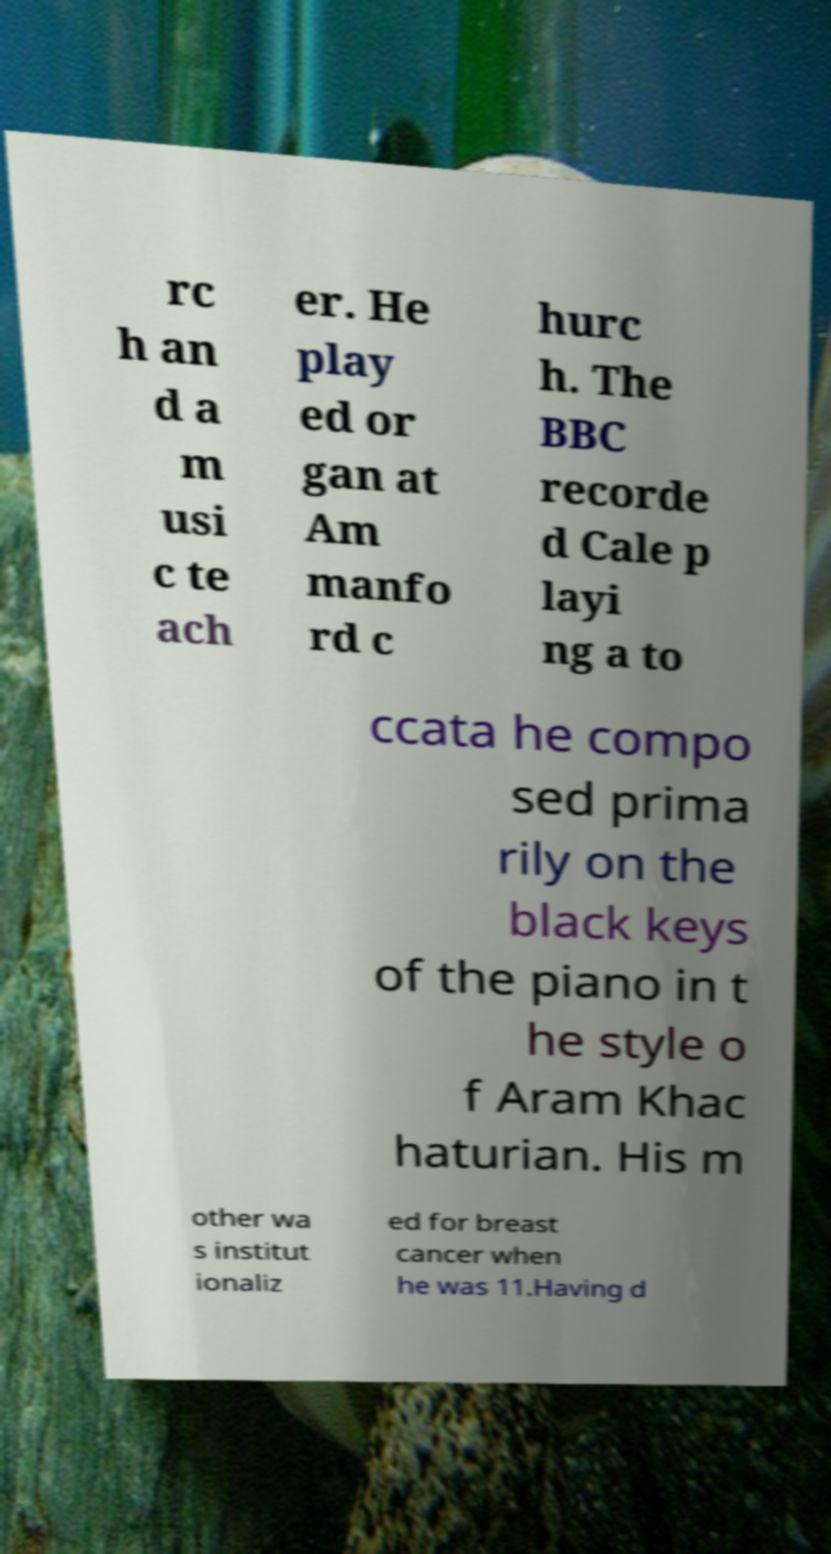For documentation purposes, I need the text within this image transcribed. Could you provide that? rc h an d a m usi c te ach er. He play ed or gan at Am manfo rd c hurc h. The BBC recorde d Cale p layi ng a to ccata he compo sed prima rily on the black keys of the piano in t he style o f Aram Khac haturian. His m other wa s institut ionaliz ed for breast cancer when he was 11.Having d 